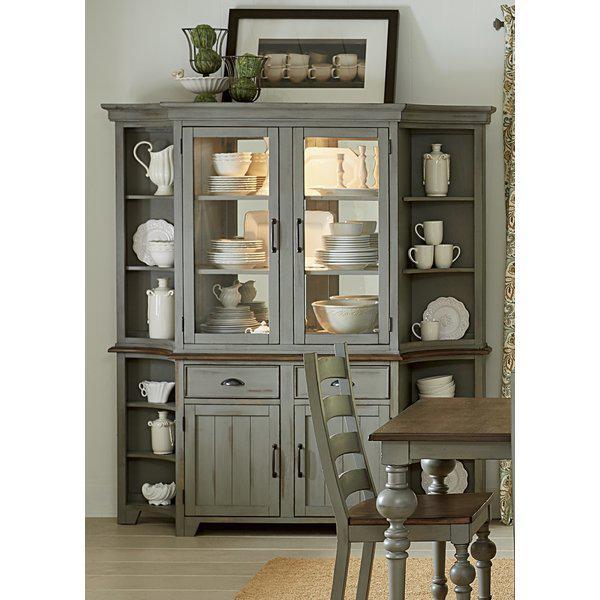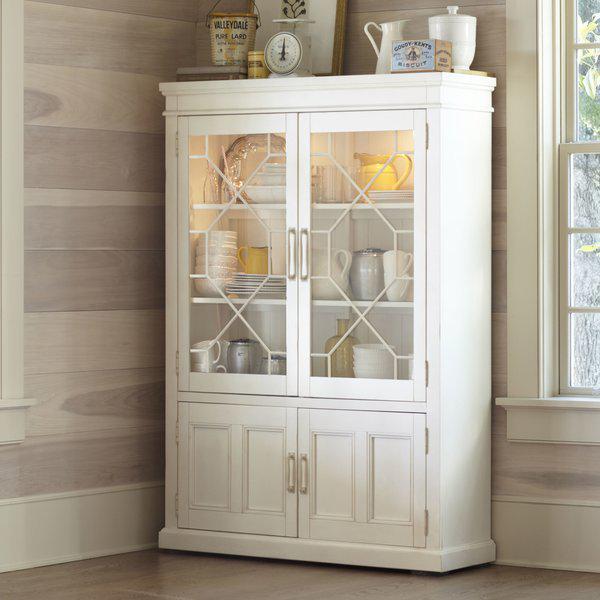The first image is the image on the left, the second image is the image on the right. Evaluate the accuracy of this statement regarding the images: "An image shows a two-door cabinet that is flat on top and has no visible feet.". Is it true? Answer yes or no. Yes. The first image is the image on the left, the second image is the image on the right. For the images shown, is this caption "Each large wooden hutch as two equal size glass doors in the upper section and two equal size solid doors in the lower section." true? Answer yes or no. Yes. 